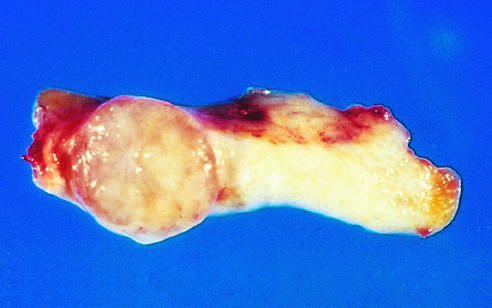s the tan-colored, encapsulated small tumor sharply demarcated from the whiter breast tissue?
Answer the question using a single word or phrase. Yes 